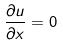<formula> <loc_0><loc_0><loc_500><loc_500>\frac { \partial u } { \partial x } = 0</formula> 